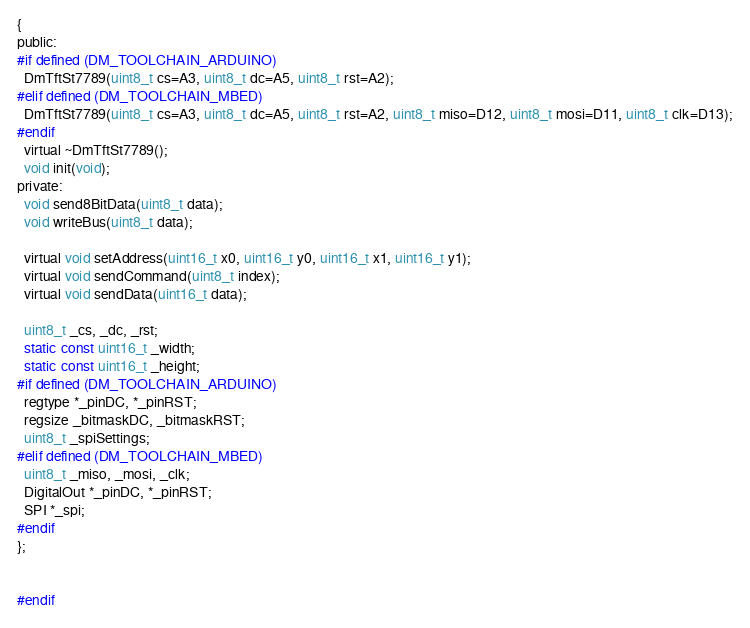Convert code to text. <code><loc_0><loc_0><loc_500><loc_500><_C_>{
public:
#if defined (DM_TOOLCHAIN_ARDUINO)
  DmTftSt7789(uint8_t cs=A3, uint8_t dc=A5, uint8_t rst=A2);
#elif defined (DM_TOOLCHAIN_MBED)
  DmTftSt7789(uint8_t cs=A3, uint8_t dc=A5, uint8_t rst=A2, uint8_t miso=D12, uint8_t mosi=D11, uint8_t clk=D13);
#endif
  virtual ~DmTftSt7789();
  void init(void);
private:
  void send8BitData(uint8_t data);
  void writeBus(uint8_t data);

  virtual void setAddress(uint16_t x0, uint16_t y0, uint16_t x1, uint16_t y1);
  virtual void sendCommand(uint8_t index);
  virtual void sendData(uint16_t data);

  uint8_t _cs, _dc, _rst;
  static const uint16_t _width;
  static const uint16_t _height;
#if defined (DM_TOOLCHAIN_ARDUINO)
  regtype *_pinDC, *_pinRST;
  regsize _bitmaskDC, _bitmaskRST;
  uint8_t _spiSettings;
#elif defined (DM_TOOLCHAIN_MBED)
  uint8_t _miso, _mosi, _clk;
  DigitalOut *_pinDC, *_pinRST;
  SPI *_spi;
#endif
};


#endif


</code> 